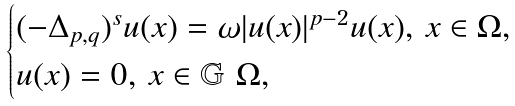Convert formula to latex. <formula><loc_0><loc_0><loc_500><loc_500>\begin{cases} ( - \Delta _ { p , q } ) ^ { s } u ( x ) = \omega | u ( x ) | ^ { p - 2 } u ( x ) , \, x \in \Omega , \\ u ( x ) = 0 , \, x \in \mathbb { G } \ \Omega , \end{cases}</formula> 